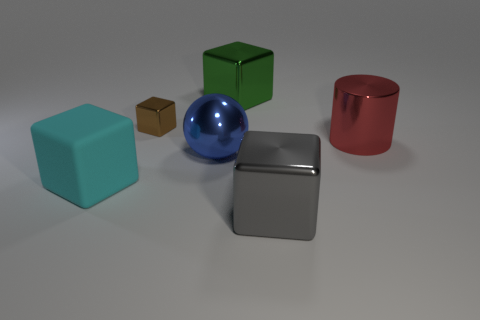Subtract 1 blocks. How many blocks are left? 3 Subtract all blocks. How many objects are left? 2 Add 2 purple metallic spheres. How many objects exist? 8 Subtract all gray blocks. Subtract all small metal things. How many objects are left? 4 Add 5 large gray shiny cubes. How many large gray shiny cubes are left? 6 Add 5 balls. How many balls exist? 6 Subtract 1 red cylinders. How many objects are left? 5 